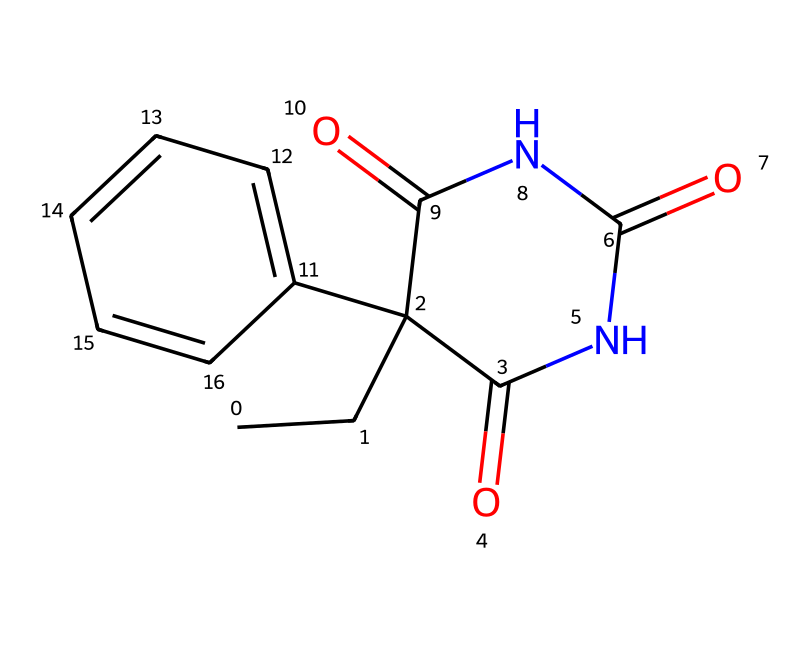What is the molecular formula of phenobarbital? To find the molecular formula, count the number of each type of atom in the structure represented by the SMILES notation. The counts indicate 12 carbons, 12 hydrogens, 4 nitrogens, and 4 oxygens, leading to the formula C12H12N2O4.
Answer: C12H12N2O4 How many rings are present in the structure? Examine the structure and identify any enclosed cyclic structures. In this molecule, there is one cyclic structure represented which forms a bicyclic system.
Answer: 1 What type of chemical bonding is predominant in phenobarbital? The structure indicates that there are multiple covalent bonds, including both single and double bonds throughout the molecule, predominantly between carbon and nitrogen atoms as well as between carbon and oxygen.
Answer: covalent What is the significance of nitrogen atoms in phenobarbital? The presence of nitrogen, specifically in the context of phenobarbital, suggests that it is a barbiturate, which is crucial for its function as an anticonvulsant. Barbiturates typically contain nitrogen atoms in their structure that contribute to their pharmacological properties.
Answer: anticonvulsant What functional groups are indicated in the structure of phenobarbital? By analyzing the structure, one can identify amide (due to the presence of nitrogen and carbonyl groups) and aromatic groups (due to the benzene ring). The distinct functional groups influence its chemical behavior and therapeutic effects.
Answer: amide and aromatic What element(s) contribute to the drug's sedative properties? The presence of nitrogen atoms is significant because the amide functional group in the structure is associated with sedative effects typical of barbiturates, including phenobarbital.
Answer: nitrogen How many oxygen atoms are in phenobarbital? Count the number of oxygen atoms present in the structure. In this case, the structure indicates there are four oxygen atoms that are key to forming functional groups that govern the drug's activity.
Answer: 4 